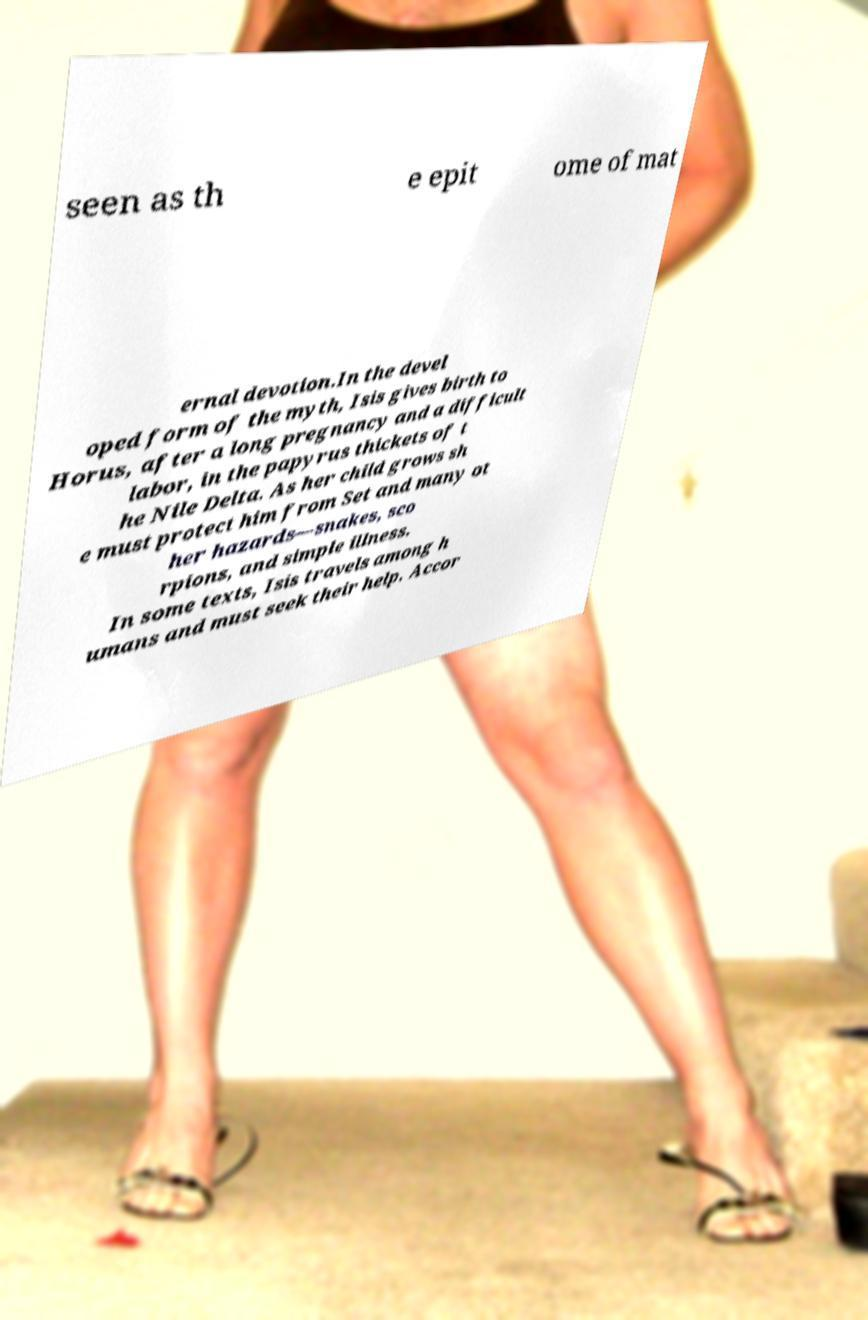Please identify and transcribe the text found in this image. seen as th e epit ome of mat ernal devotion.In the devel oped form of the myth, Isis gives birth to Horus, after a long pregnancy and a difficult labor, in the papyrus thickets of t he Nile Delta. As her child grows sh e must protect him from Set and many ot her hazards—snakes, sco rpions, and simple illness. In some texts, Isis travels among h umans and must seek their help. Accor 